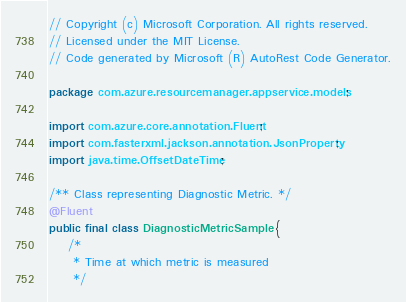<code> <loc_0><loc_0><loc_500><loc_500><_Java_>// Copyright (c) Microsoft Corporation. All rights reserved.
// Licensed under the MIT License.
// Code generated by Microsoft (R) AutoRest Code Generator.

package com.azure.resourcemanager.appservice.models;

import com.azure.core.annotation.Fluent;
import com.fasterxml.jackson.annotation.JsonProperty;
import java.time.OffsetDateTime;

/** Class representing Diagnostic Metric. */
@Fluent
public final class DiagnosticMetricSample {
    /*
     * Time at which metric is measured
     */</code> 